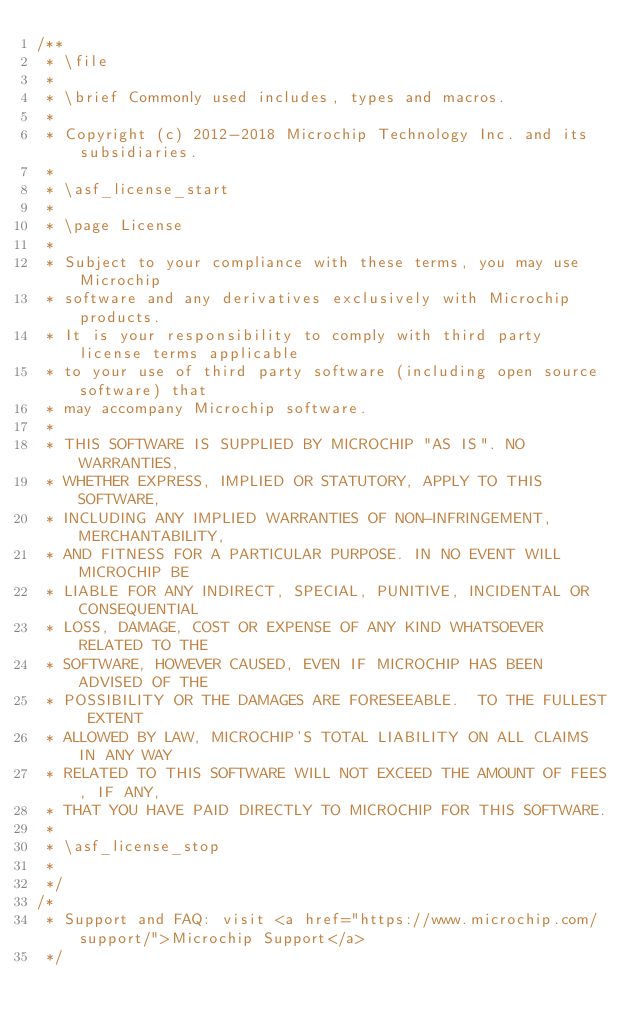Convert code to text. <code><loc_0><loc_0><loc_500><loc_500><_C_>/**
 * \file
 *
 * \brief Commonly used includes, types and macros.
 *
 * Copyright (c) 2012-2018 Microchip Technology Inc. and its subsidiaries.
 *
 * \asf_license_start
 *
 * \page License
 *
 * Subject to your compliance with these terms, you may use Microchip
 * software and any derivatives exclusively with Microchip products.
 * It is your responsibility to comply with third party license terms applicable
 * to your use of third party software (including open source software) that
 * may accompany Microchip software.
 *
 * THIS SOFTWARE IS SUPPLIED BY MICROCHIP "AS IS". NO WARRANTIES,
 * WHETHER EXPRESS, IMPLIED OR STATUTORY, APPLY TO THIS SOFTWARE,
 * INCLUDING ANY IMPLIED WARRANTIES OF NON-INFRINGEMENT, MERCHANTABILITY,
 * AND FITNESS FOR A PARTICULAR PURPOSE. IN NO EVENT WILL MICROCHIP BE
 * LIABLE FOR ANY INDIRECT, SPECIAL, PUNITIVE, INCIDENTAL OR CONSEQUENTIAL
 * LOSS, DAMAGE, COST OR EXPENSE OF ANY KIND WHATSOEVER RELATED TO THE
 * SOFTWARE, HOWEVER CAUSED, EVEN IF MICROCHIP HAS BEEN ADVISED OF THE
 * POSSIBILITY OR THE DAMAGES ARE FORESEEABLE.  TO THE FULLEST EXTENT
 * ALLOWED BY LAW, MICROCHIP'S TOTAL LIABILITY ON ALL CLAIMS IN ANY WAY
 * RELATED TO THIS SOFTWARE WILL NOT EXCEED THE AMOUNT OF FEES, IF ANY,
 * THAT YOU HAVE PAID DIRECTLY TO MICROCHIP FOR THIS SOFTWARE.
 *
 * \asf_license_stop
 *
 */
/*
 * Support and FAQ: visit <a href="https://www.microchip.com/support/">Microchip Support</a>
 */
</code> 